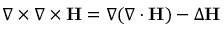<formula> <loc_0><loc_0><loc_500><loc_500>\nabla \times \nabla \times H = \nabla ( \nabla \cdot H ) - \Delta H</formula> 